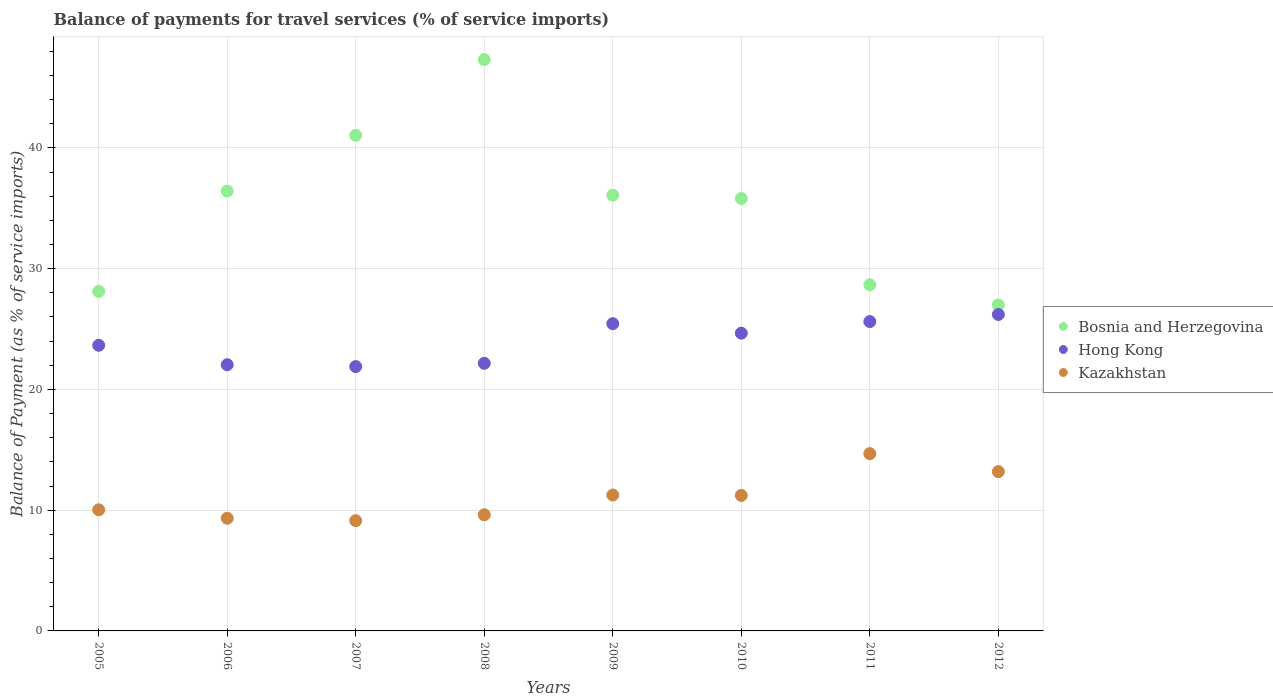What is the balance of payments for travel services in Kazakhstan in 2012?
Your answer should be compact. 13.19. Across all years, what is the maximum balance of payments for travel services in Hong Kong?
Ensure brevity in your answer.  26.2. Across all years, what is the minimum balance of payments for travel services in Hong Kong?
Make the answer very short. 21.89. What is the total balance of payments for travel services in Kazakhstan in the graph?
Your answer should be very brief. 88.45. What is the difference between the balance of payments for travel services in Kazakhstan in 2009 and that in 2011?
Offer a very short reply. -3.43. What is the difference between the balance of payments for travel services in Kazakhstan in 2011 and the balance of payments for travel services in Bosnia and Herzegovina in 2012?
Provide a short and direct response. -12.31. What is the average balance of payments for travel services in Hong Kong per year?
Your answer should be very brief. 23.96. In the year 2012, what is the difference between the balance of payments for travel services in Hong Kong and balance of payments for travel services in Bosnia and Herzegovina?
Your answer should be compact. -0.79. In how many years, is the balance of payments for travel services in Kazakhstan greater than 2 %?
Keep it short and to the point. 8. What is the ratio of the balance of payments for travel services in Hong Kong in 2006 to that in 2011?
Your answer should be very brief. 0.86. Is the balance of payments for travel services in Kazakhstan in 2006 less than that in 2007?
Provide a succinct answer. No. Is the difference between the balance of payments for travel services in Hong Kong in 2007 and 2012 greater than the difference between the balance of payments for travel services in Bosnia and Herzegovina in 2007 and 2012?
Your response must be concise. No. What is the difference between the highest and the second highest balance of payments for travel services in Bosnia and Herzegovina?
Ensure brevity in your answer.  6.27. What is the difference between the highest and the lowest balance of payments for travel services in Kazakhstan?
Make the answer very short. 5.55. Is it the case that in every year, the sum of the balance of payments for travel services in Bosnia and Herzegovina and balance of payments for travel services in Hong Kong  is greater than the balance of payments for travel services in Kazakhstan?
Give a very brief answer. Yes. Does the balance of payments for travel services in Hong Kong monotonically increase over the years?
Make the answer very short. No. Is the balance of payments for travel services in Hong Kong strictly greater than the balance of payments for travel services in Bosnia and Herzegovina over the years?
Make the answer very short. No. Is the balance of payments for travel services in Kazakhstan strictly less than the balance of payments for travel services in Bosnia and Herzegovina over the years?
Give a very brief answer. Yes. How many dotlines are there?
Provide a succinct answer. 3. Are the values on the major ticks of Y-axis written in scientific E-notation?
Your answer should be very brief. No. Does the graph contain any zero values?
Provide a succinct answer. No. Does the graph contain grids?
Provide a short and direct response. Yes. How many legend labels are there?
Ensure brevity in your answer.  3. What is the title of the graph?
Ensure brevity in your answer.  Balance of payments for travel services (% of service imports). What is the label or title of the Y-axis?
Provide a succinct answer. Balance of Payment (as % of service imports). What is the Balance of Payment (as % of service imports) in Bosnia and Herzegovina in 2005?
Your answer should be compact. 28.11. What is the Balance of Payment (as % of service imports) in Hong Kong in 2005?
Your response must be concise. 23.65. What is the Balance of Payment (as % of service imports) in Kazakhstan in 2005?
Provide a succinct answer. 10.03. What is the Balance of Payment (as % of service imports) of Bosnia and Herzegovina in 2006?
Provide a short and direct response. 36.42. What is the Balance of Payment (as % of service imports) of Hong Kong in 2006?
Keep it short and to the point. 22.04. What is the Balance of Payment (as % of service imports) in Kazakhstan in 2006?
Make the answer very short. 9.33. What is the Balance of Payment (as % of service imports) in Bosnia and Herzegovina in 2007?
Your response must be concise. 41.04. What is the Balance of Payment (as % of service imports) in Hong Kong in 2007?
Provide a short and direct response. 21.89. What is the Balance of Payment (as % of service imports) in Kazakhstan in 2007?
Make the answer very short. 9.13. What is the Balance of Payment (as % of service imports) of Bosnia and Herzegovina in 2008?
Your answer should be very brief. 47.31. What is the Balance of Payment (as % of service imports) of Hong Kong in 2008?
Your answer should be very brief. 22.16. What is the Balance of Payment (as % of service imports) in Kazakhstan in 2008?
Offer a very short reply. 9.62. What is the Balance of Payment (as % of service imports) in Bosnia and Herzegovina in 2009?
Your answer should be compact. 36.08. What is the Balance of Payment (as % of service imports) in Hong Kong in 2009?
Ensure brevity in your answer.  25.44. What is the Balance of Payment (as % of service imports) of Kazakhstan in 2009?
Your answer should be very brief. 11.25. What is the Balance of Payment (as % of service imports) in Bosnia and Herzegovina in 2010?
Give a very brief answer. 35.81. What is the Balance of Payment (as % of service imports) in Hong Kong in 2010?
Keep it short and to the point. 24.66. What is the Balance of Payment (as % of service imports) in Kazakhstan in 2010?
Make the answer very short. 11.22. What is the Balance of Payment (as % of service imports) of Bosnia and Herzegovina in 2011?
Offer a very short reply. 28.67. What is the Balance of Payment (as % of service imports) in Hong Kong in 2011?
Your response must be concise. 25.62. What is the Balance of Payment (as % of service imports) in Kazakhstan in 2011?
Your answer should be compact. 14.68. What is the Balance of Payment (as % of service imports) in Bosnia and Herzegovina in 2012?
Your answer should be very brief. 26.99. What is the Balance of Payment (as % of service imports) in Hong Kong in 2012?
Keep it short and to the point. 26.2. What is the Balance of Payment (as % of service imports) of Kazakhstan in 2012?
Your answer should be compact. 13.19. Across all years, what is the maximum Balance of Payment (as % of service imports) of Bosnia and Herzegovina?
Your answer should be very brief. 47.31. Across all years, what is the maximum Balance of Payment (as % of service imports) of Hong Kong?
Offer a very short reply. 26.2. Across all years, what is the maximum Balance of Payment (as % of service imports) of Kazakhstan?
Your response must be concise. 14.68. Across all years, what is the minimum Balance of Payment (as % of service imports) of Bosnia and Herzegovina?
Your answer should be very brief. 26.99. Across all years, what is the minimum Balance of Payment (as % of service imports) of Hong Kong?
Offer a very short reply. 21.89. Across all years, what is the minimum Balance of Payment (as % of service imports) in Kazakhstan?
Make the answer very short. 9.13. What is the total Balance of Payment (as % of service imports) of Bosnia and Herzegovina in the graph?
Give a very brief answer. 280.43. What is the total Balance of Payment (as % of service imports) in Hong Kong in the graph?
Give a very brief answer. 191.67. What is the total Balance of Payment (as % of service imports) in Kazakhstan in the graph?
Your response must be concise. 88.45. What is the difference between the Balance of Payment (as % of service imports) in Bosnia and Herzegovina in 2005 and that in 2006?
Ensure brevity in your answer.  -8.31. What is the difference between the Balance of Payment (as % of service imports) of Hong Kong in 2005 and that in 2006?
Give a very brief answer. 1.61. What is the difference between the Balance of Payment (as % of service imports) in Kazakhstan in 2005 and that in 2006?
Offer a terse response. 0.7. What is the difference between the Balance of Payment (as % of service imports) of Bosnia and Herzegovina in 2005 and that in 2007?
Provide a succinct answer. -12.93. What is the difference between the Balance of Payment (as % of service imports) in Hong Kong in 2005 and that in 2007?
Your response must be concise. 1.76. What is the difference between the Balance of Payment (as % of service imports) of Kazakhstan in 2005 and that in 2007?
Your answer should be compact. 0.9. What is the difference between the Balance of Payment (as % of service imports) in Bosnia and Herzegovina in 2005 and that in 2008?
Provide a succinct answer. -19.19. What is the difference between the Balance of Payment (as % of service imports) of Hong Kong in 2005 and that in 2008?
Your answer should be very brief. 1.49. What is the difference between the Balance of Payment (as % of service imports) in Kazakhstan in 2005 and that in 2008?
Ensure brevity in your answer.  0.41. What is the difference between the Balance of Payment (as % of service imports) in Bosnia and Herzegovina in 2005 and that in 2009?
Your response must be concise. -7.97. What is the difference between the Balance of Payment (as % of service imports) in Hong Kong in 2005 and that in 2009?
Give a very brief answer. -1.79. What is the difference between the Balance of Payment (as % of service imports) of Kazakhstan in 2005 and that in 2009?
Your response must be concise. -1.22. What is the difference between the Balance of Payment (as % of service imports) in Bosnia and Herzegovina in 2005 and that in 2010?
Offer a very short reply. -7.69. What is the difference between the Balance of Payment (as % of service imports) in Hong Kong in 2005 and that in 2010?
Give a very brief answer. -1. What is the difference between the Balance of Payment (as % of service imports) in Kazakhstan in 2005 and that in 2010?
Offer a very short reply. -1.19. What is the difference between the Balance of Payment (as % of service imports) in Bosnia and Herzegovina in 2005 and that in 2011?
Your answer should be compact. -0.55. What is the difference between the Balance of Payment (as % of service imports) in Hong Kong in 2005 and that in 2011?
Your response must be concise. -1.96. What is the difference between the Balance of Payment (as % of service imports) in Kazakhstan in 2005 and that in 2011?
Offer a terse response. -4.65. What is the difference between the Balance of Payment (as % of service imports) in Bosnia and Herzegovina in 2005 and that in 2012?
Provide a succinct answer. 1.12. What is the difference between the Balance of Payment (as % of service imports) of Hong Kong in 2005 and that in 2012?
Keep it short and to the point. -2.55. What is the difference between the Balance of Payment (as % of service imports) in Kazakhstan in 2005 and that in 2012?
Keep it short and to the point. -3.16. What is the difference between the Balance of Payment (as % of service imports) in Bosnia and Herzegovina in 2006 and that in 2007?
Give a very brief answer. -4.62. What is the difference between the Balance of Payment (as % of service imports) of Hong Kong in 2006 and that in 2007?
Give a very brief answer. 0.15. What is the difference between the Balance of Payment (as % of service imports) in Kazakhstan in 2006 and that in 2007?
Give a very brief answer. 0.2. What is the difference between the Balance of Payment (as % of service imports) of Bosnia and Herzegovina in 2006 and that in 2008?
Give a very brief answer. -10.88. What is the difference between the Balance of Payment (as % of service imports) in Hong Kong in 2006 and that in 2008?
Your response must be concise. -0.12. What is the difference between the Balance of Payment (as % of service imports) in Kazakhstan in 2006 and that in 2008?
Offer a terse response. -0.29. What is the difference between the Balance of Payment (as % of service imports) in Bosnia and Herzegovina in 2006 and that in 2009?
Your answer should be compact. 0.34. What is the difference between the Balance of Payment (as % of service imports) of Hong Kong in 2006 and that in 2009?
Offer a very short reply. -3.4. What is the difference between the Balance of Payment (as % of service imports) of Kazakhstan in 2006 and that in 2009?
Offer a very short reply. -1.92. What is the difference between the Balance of Payment (as % of service imports) in Bosnia and Herzegovina in 2006 and that in 2010?
Make the answer very short. 0.62. What is the difference between the Balance of Payment (as % of service imports) in Hong Kong in 2006 and that in 2010?
Your answer should be compact. -2.61. What is the difference between the Balance of Payment (as % of service imports) in Kazakhstan in 2006 and that in 2010?
Your answer should be very brief. -1.89. What is the difference between the Balance of Payment (as % of service imports) of Bosnia and Herzegovina in 2006 and that in 2011?
Ensure brevity in your answer.  7.76. What is the difference between the Balance of Payment (as % of service imports) of Hong Kong in 2006 and that in 2011?
Your answer should be compact. -3.57. What is the difference between the Balance of Payment (as % of service imports) in Kazakhstan in 2006 and that in 2011?
Your response must be concise. -5.35. What is the difference between the Balance of Payment (as % of service imports) of Bosnia and Herzegovina in 2006 and that in 2012?
Keep it short and to the point. 9.43. What is the difference between the Balance of Payment (as % of service imports) in Hong Kong in 2006 and that in 2012?
Ensure brevity in your answer.  -4.16. What is the difference between the Balance of Payment (as % of service imports) in Kazakhstan in 2006 and that in 2012?
Make the answer very short. -3.86. What is the difference between the Balance of Payment (as % of service imports) in Bosnia and Herzegovina in 2007 and that in 2008?
Keep it short and to the point. -6.27. What is the difference between the Balance of Payment (as % of service imports) of Hong Kong in 2007 and that in 2008?
Provide a short and direct response. -0.27. What is the difference between the Balance of Payment (as % of service imports) in Kazakhstan in 2007 and that in 2008?
Ensure brevity in your answer.  -0.49. What is the difference between the Balance of Payment (as % of service imports) of Bosnia and Herzegovina in 2007 and that in 2009?
Provide a succinct answer. 4.96. What is the difference between the Balance of Payment (as % of service imports) in Hong Kong in 2007 and that in 2009?
Ensure brevity in your answer.  -3.55. What is the difference between the Balance of Payment (as % of service imports) in Kazakhstan in 2007 and that in 2009?
Offer a very short reply. -2.12. What is the difference between the Balance of Payment (as % of service imports) of Bosnia and Herzegovina in 2007 and that in 2010?
Give a very brief answer. 5.23. What is the difference between the Balance of Payment (as % of service imports) in Hong Kong in 2007 and that in 2010?
Your response must be concise. -2.77. What is the difference between the Balance of Payment (as % of service imports) of Kazakhstan in 2007 and that in 2010?
Give a very brief answer. -2.09. What is the difference between the Balance of Payment (as % of service imports) in Bosnia and Herzegovina in 2007 and that in 2011?
Offer a terse response. 12.37. What is the difference between the Balance of Payment (as % of service imports) in Hong Kong in 2007 and that in 2011?
Your answer should be compact. -3.73. What is the difference between the Balance of Payment (as % of service imports) of Kazakhstan in 2007 and that in 2011?
Make the answer very short. -5.55. What is the difference between the Balance of Payment (as % of service imports) of Bosnia and Herzegovina in 2007 and that in 2012?
Your response must be concise. 14.05. What is the difference between the Balance of Payment (as % of service imports) in Hong Kong in 2007 and that in 2012?
Offer a terse response. -4.31. What is the difference between the Balance of Payment (as % of service imports) of Kazakhstan in 2007 and that in 2012?
Your response must be concise. -4.06. What is the difference between the Balance of Payment (as % of service imports) in Bosnia and Herzegovina in 2008 and that in 2009?
Keep it short and to the point. 11.23. What is the difference between the Balance of Payment (as % of service imports) in Hong Kong in 2008 and that in 2009?
Your response must be concise. -3.28. What is the difference between the Balance of Payment (as % of service imports) in Kazakhstan in 2008 and that in 2009?
Offer a terse response. -1.63. What is the difference between the Balance of Payment (as % of service imports) in Bosnia and Herzegovina in 2008 and that in 2010?
Your answer should be compact. 11.5. What is the difference between the Balance of Payment (as % of service imports) in Hong Kong in 2008 and that in 2010?
Keep it short and to the point. -2.49. What is the difference between the Balance of Payment (as % of service imports) in Kazakhstan in 2008 and that in 2010?
Make the answer very short. -1.6. What is the difference between the Balance of Payment (as % of service imports) in Bosnia and Herzegovina in 2008 and that in 2011?
Provide a short and direct response. 18.64. What is the difference between the Balance of Payment (as % of service imports) of Hong Kong in 2008 and that in 2011?
Your answer should be compact. -3.45. What is the difference between the Balance of Payment (as % of service imports) in Kazakhstan in 2008 and that in 2011?
Provide a short and direct response. -5.06. What is the difference between the Balance of Payment (as % of service imports) in Bosnia and Herzegovina in 2008 and that in 2012?
Make the answer very short. 20.32. What is the difference between the Balance of Payment (as % of service imports) of Hong Kong in 2008 and that in 2012?
Provide a short and direct response. -4.04. What is the difference between the Balance of Payment (as % of service imports) of Kazakhstan in 2008 and that in 2012?
Provide a short and direct response. -3.57. What is the difference between the Balance of Payment (as % of service imports) of Bosnia and Herzegovina in 2009 and that in 2010?
Your answer should be very brief. 0.28. What is the difference between the Balance of Payment (as % of service imports) in Hong Kong in 2009 and that in 2010?
Your response must be concise. 0.79. What is the difference between the Balance of Payment (as % of service imports) of Kazakhstan in 2009 and that in 2010?
Provide a succinct answer. 0.03. What is the difference between the Balance of Payment (as % of service imports) of Bosnia and Herzegovina in 2009 and that in 2011?
Make the answer very short. 7.42. What is the difference between the Balance of Payment (as % of service imports) in Hong Kong in 2009 and that in 2011?
Ensure brevity in your answer.  -0.17. What is the difference between the Balance of Payment (as % of service imports) of Kazakhstan in 2009 and that in 2011?
Your answer should be compact. -3.43. What is the difference between the Balance of Payment (as % of service imports) of Bosnia and Herzegovina in 2009 and that in 2012?
Ensure brevity in your answer.  9.09. What is the difference between the Balance of Payment (as % of service imports) in Hong Kong in 2009 and that in 2012?
Offer a very short reply. -0.76. What is the difference between the Balance of Payment (as % of service imports) of Kazakhstan in 2009 and that in 2012?
Your answer should be very brief. -1.94. What is the difference between the Balance of Payment (as % of service imports) of Bosnia and Herzegovina in 2010 and that in 2011?
Keep it short and to the point. 7.14. What is the difference between the Balance of Payment (as % of service imports) of Hong Kong in 2010 and that in 2011?
Your answer should be very brief. -0.96. What is the difference between the Balance of Payment (as % of service imports) in Kazakhstan in 2010 and that in 2011?
Provide a short and direct response. -3.46. What is the difference between the Balance of Payment (as % of service imports) of Bosnia and Herzegovina in 2010 and that in 2012?
Provide a succinct answer. 8.82. What is the difference between the Balance of Payment (as % of service imports) of Hong Kong in 2010 and that in 2012?
Keep it short and to the point. -1.55. What is the difference between the Balance of Payment (as % of service imports) in Kazakhstan in 2010 and that in 2012?
Your answer should be very brief. -1.97. What is the difference between the Balance of Payment (as % of service imports) in Bosnia and Herzegovina in 2011 and that in 2012?
Provide a succinct answer. 1.67. What is the difference between the Balance of Payment (as % of service imports) in Hong Kong in 2011 and that in 2012?
Your response must be concise. -0.59. What is the difference between the Balance of Payment (as % of service imports) of Kazakhstan in 2011 and that in 2012?
Provide a succinct answer. 1.49. What is the difference between the Balance of Payment (as % of service imports) of Bosnia and Herzegovina in 2005 and the Balance of Payment (as % of service imports) of Hong Kong in 2006?
Your answer should be very brief. 6.07. What is the difference between the Balance of Payment (as % of service imports) in Bosnia and Herzegovina in 2005 and the Balance of Payment (as % of service imports) in Kazakhstan in 2006?
Your answer should be compact. 18.79. What is the difference between the Balance of Payment (as % of service imports) of Hong Kong in 2005 and the Balance of Payment (as % of service imports) of Kazakhstan in 2006?
Your answer should be very brief. 14.32. What is the difference between the Balance of Payment (as % of service imports) in Bosnia and Herzegovina in 2005 and the Balance of Payment (as % of service imports) in Hong Kong in 2007?
Provide a short and direct response. 6.22. What is the difference between the Balance of Payment (as % of service imports) of Bosnia and Herzegovina in 2005 and the Balance of Payment (as % of service imports) of Kazakhstan in 2007?
Your answer should be compact. 18.99. What is the difference between the Balance of Payment (as % of service imports) of Hong Kong in 2005 and the Balance of Payment (as % of service imports) of Kazakhstan in 2007?
Provide a short and direct response. 14.52. What is the difference between the Balance of Payment (as % of service imports) in Bosnia and Herzegovina in 2005 and the Balance of Payment (as % of service imports) in Hong Kong in 2008?
Ensure brevity in your answer.  5.95. What is the difference between the Balance of Payment (as % of service imports) in Bosnia and Herzegovina in 2005 and the Balance of Payment (as % of service imports) in Kazakhstan in 2008?
Provide a succinct answer. 18.5. What is the difference between the Balance of Payment (as % of service imports) in Hong Kong in 2005 and the Balance of Payment (as % of service imports) in Kazakhstan in 2008?
Make the answer very short. 14.03. What is the difference between the Balance of Payment (as % of service imports) of Bosnia and Herzegovina in 2005 and the Balance of Payment (as % of service imports) of Hong Kong in 2009?
Your answer should be very brief. 2.67. What is the difference between the Balance of Payment (as % of service imports) in Bosnia and Herzegovina in 2005 and the Balance of Payment (as % of service imports) in Kazakhstan in 2009?
Your answer should be compact. 16.86. What is the difference between the Balance of Payment (as % of service imports) in Hong Kong in 2005 and the Balance of Payment (as % of service imports) in Kazakhstan in 2009?
Your response must be concise. 12.4. What is the difference between the Balance of Payment (as % of service imports) of Bosnia and Herzegovina in 2005 and the Balance of Payment (as % of service imports) of Hong Kong in 2010?
Ensure brevity in your answer.  3.46. What is the difference between the Balance of Payment (as % of service imports) of Bosnia and Herzegovina in 2005 and the Balance of Payment (as % of service imports) of Kazakhstan in 2010?
Offer a very short reply. 16.89. What is the difference between the Balance of Payment (as % of service imports) in Hong Kong in 2005 and the Balance of Payment (as % of service imports) in Kazakhstan in 2010?
Make the answer very short. 12.43. What is the difference between the Balance of Payment (as % of service imports) of Bosnia and Herzegovina in 2005 and the Balance of Payment (as % of service imports) of Hong Kong in 2011?
Provide a short and direct response. 2.5. What is the difference between the Balance of Payment (as % of service imports) of Bosnia and Herzegovina in 2005 and the Balance of Payment (as % of service imports) of Kazakhstan in 2011?
Give a very brief answer. 13.44. What is the difference between the Balance of Payment (as % of service imports) in Hong Kong in 2005 and the Balance of Payment (as % of service imports) in Kazakhstan in 2011?
Offer a very short reply. 8.97. What is the difference between the Balance of Payment (as % of service imports) of Bosnia and Herzegovina in 2005 and the Balance of Payment (as % of service imports) of Hong Kong in 2012?
Give a very brief answer. 1.91. What is the difference between the Balance of Payment (as % of service imports) of Bosnia and Herzegovina in 2005 and the Balance of Payment (as % of service imports) of Kazakhstan in 2012?
Keep it short and to the point. 14.93. What is the difference between the Balance of Payment (as % of service imports) of Hong Kong in 2005 and the Balance of Payment (as % of service imports) of Kazakhstan in 2012?
Offer a very short reply. 10.46. What is the difference between the Balance of Payment (as % of service imports) in Bosnia and Herzegovina in 2006 and the Balance of Payment (as % of service imports) in Hong Kong in 2007?
Provide a short and direct response. 14.53. What is the difference between the Balance of Payment (as % of service imports) in Bosnia and Herzegovina in 2006 and the Balance of Payment (as % of service imports) in Kazakhstan in 2007?
Keep it short and to the point. 27.3. What is the difference between the Balance of Payment (as % of service imports) of Hong Kong in 2006 and the Balance of Payment (as % of service imports) of Kazakhstan in 2007?
Give a very brief answer. 12.92. What is the difference between the Balance of Payment (as % of service imports) in Bosnia and Herzegovina in 2006 and the Balance of Payment (as % of service imports) in Hong Kong in 2008?
Provide a succinct answer. 14.26. What is the difference between the Balance of Payment (as % of service imports) of Bosnia and Herzegovina in 2006 and the Balance of Payment (as % of service imports) of Kazakhstan in 2008?
Offer a very short reply. 26.8. What is the difference between the Balance of Payment (as % of service imports) of Hong Kong in 2006 and the Balance of Payment (as % of service imports) of Kazakhstan in 2008?
Keep it short and to the point. 12.42. What is the difference between the Balance of Payment (as % of service imports) of Bosnia and Herzegovina in 2006 and the Balance of Payment (as % of service imports) of Hong Kong in 2009?
Keep it short and to the point. 10.98. What is the difference between the Balance of Payment (as % of service imports) in Bosnia and Herzegovina in 2006 and the Balance of Payment (as % of service imports) in Kazakhstan in 2009?
Provide a short and direct response. 25.17. What is the difference between the Balance of Payment (as % of service imports) in Hong Kong in 2006 and the Balance of Payment (as % of service imports) in Kazakhstan in 2009?
Keep it short and to the point. 10.79. What is the difference between the Balance of Payment (as % of service imports) of Bosnia and Herzegovina in 2006 and the Balance of Payment (as % of service imports) of Hong Kong in 2010?
Provide a succinct answer. 11.77. What is the difference between the Balance of Payment (as % of service imports) of Bosnia and Herzegovina in 2006 and the Balance of Payment (as % of service imports) of Kazakhstan in 2010?
Offer a very short reply. 25.2. What is the difference between the Balance of Payment (as % of service imports) of Hong Kong in 2006 and the Balance of Payment (as % of service imports) of Kazakhstan in 2010?
Offer a very short reply. 10.82. What is the difference between the Balance of Payment (as % of service imports) of Bosnia and Herzegovina in 2006 and the Balance of Payment (as % of service imports) of Hong Kong in 2011?
Your response must be concise. 10.81. What is the difference between the Balance of Payment (as % of service imports) of Bosnia and Herzegovina in 2006 and the Balance of Payment (as % of service imports) of Kazakhstan in 2011?
Your answer should be compact. 21.74. What is the difference between the Balance of Payment (as % of service imports) in Hong Kong in 2006 and the Balance of Payment (as % of service imports) in Kazakhstan in 2011?
Ensure brevity in your answer.  7.36. What is the difference between the Balance of Payment (as % of service imports) of Bosnia and Herzegovina in 2006 and the Balance of Payment (as % of service imports) of Hong Kong in 2012?
Your answer should be very brief. 10.22. What is the difference between the Balance of Payment (as % of service imports) of Bosnia and Herzegovina in 2006 and the Balance of Payment (as % of service imports) of Kazakhstan in 2012?
Offer a very short reply. 23.23. What is the difference between the Balance of Payment (as % of service imports) in Hong Kong in 2006 and the Balance of Payment (as % of service imports) in Kazakhstan in 2012?
Make the answer very short. 8.85. What is the difference between the Balance of Payment (as % of service imports) of Bosnia and Herzegovina in 2007 and the Balance of Payment (as % of service imports) of Hong Kong in 2008?
Provide a succinct answer. 18.88. What is the difference between the Balance of Payment (as % of service imports) in Bosnia and Herzegovina in 2007 and the Balance of Payment (as % of service imports) in Kazakhstan in 2008?
Your answer should be compact. 31.42. What is the difference between the Balance of Payment (as % of service imports) of Hong Kong in 2007 and the Balance of Payment (as % of service imports) of Kazakhstan in 2008?
Keep it short and to the point. 12.27. What is the difference between the Balance of Payment (as % of service imports) in Bosnia and Herzegovina in 2007 and the Balance of Payment (as % of service imports) in Hong Kong in 2009?
Provide a short and direct response. 15.6. What is the difference between the Balance of Payment (as % of service imports) in Bosnia and Herzegovina in 2007 and the Balance of Payment (as % of service imports) in Kazakhstan in 2009?
Offer a terse response. 29.79. What is the difference between the Balance of Payment (as % of service imports) of Hong Kong in 2007 and the Balance of Payment (as % of service imports) of Kazakhstan in 2009?
Give a very brief answer. 10.64. What is the difference between the Balance of Payment (as % of service imports) in Bosnia and Herzegovina in 2007 and the Balance of Payment (as % of service imports) in Hong Kong in 2010?
Your answer should be compact. 16.38. What is the difference between the Balance of Payment (as % of service imports) in Bosnia and Herzegovina in 2007 and the Balance of Payment (as % of service imports) in Kazakhstan in 2010?
Provide a short and direct response. 29.82. What is the difference between the Balance of Payment (as % of service imports) in Hong Kong in 2007 and the Balance of Payment (as % of service imports) in Kazakhstan in 2010?
Offer a very short reply. 10.67. What is the difference between the Balance of Payment (as % of service imports) in Bosnia and Herzegovina in 2007 and the Balance of Payment (as % of service imports) in Hong Kong in 2011?
Provide a succinct answer. 15.42. What is the difference between the Balance of Payment (as % of service imports) of Bosnia and Herzegovina in 2007 and the Balance of Payment (as % of service imports) of Kazakhstan in 2011?
Make the answer very short. 26.36. What is the difference between the Balance of Payment (as % of service imports) of Hong Kong in 2007 and the Balance of Payment (as % of service imports) of Kazakhstan in 2011?
Your response must be concise. 7.21. What is the difference between the Balance of Payment (as % of service imports) of Bosnia and Herzegovina in 2007 and the Balance of Payment (as % of service imports) of Hong Kong in 2012?
Offer a very short reply. 14.84. What is the difference between the Balance of Payment (as % of service imports) in Bosnia and Herzegovina in 2007 and the Balance of Payment (as % of service imports) in Kazakhstan in 2012?
Keep it short and to the point. 27.85. What is the difference between the Balance of Payment (as % of service imports) of Hong Kong in 2007 and the Balance of Payment (as % of service imports) of Kazakhstan in 2012?
Offer a very short reply. 8.7. What is the difference between the Balance of Payment (as % of service imports) in Bosnia and Herzegovina in 2008 and the Balance of Payment (as % of service imports) in Hong Kong in 2009?
Offer a terse response. 21.86. What is the difference between the Balance of Payment (as % of service imports) in Bosnia and Herzegovina in 2008 and the Balance of Payment (as % of service imports) in Kazakhstan in 2009?
Provide a short and direct response. 36.05. What is the difference between the Balance of Payment (as % of service imports) of Hong Kong in 2008 and the Balance of Payment (as % of service imports) of Kazakhstan in 2009?
Provide a short and direct response. 10.91. What is the difference between the Balance of Payment (as % of service imports) in Bosnia and Herzegovina in 2008 and the Balance of Payment (as % of service imports) in Hong Kong in 2010?
Offer a terse response. 22.65. What is the difference between the Balance of Payment (as % of service imports) in Bosnia and Herzegovina in 2008 and the Balance of Payment (as % of service imports) in Kazakhstan in 2010?
Offer a very short reply. 36.09. What is the difference between the Balance of Payment (as % of service imports) of Hong Kong in 2008 and the Balance of Payment (as % of service imports) of Kazakhstan in 2010?
Provide a succinct answer. 10.94. What is the difference between the Balance of Payment (as % of service imports) in Bosnia and Herzegovina in 2008 and the Balance of Payment (as % of service imports) in Hong Kong in 2011?
Ensure brevity in your answer.  21.69. What is the difference between the Balance of Payment (as % of service imports) of Bosnia and Herzegovina in 2008 and the Balance of Payment (as % of service imports) of Kazakhstan in 2011?
Your answer should be compact. 32.63. What is the difference between the Balance of Payment (as % of service imports) in Hong Kong in 2008 and the Balance of Payment (as % of service imports) in Kazakhstan in 2011?
Offer a very short reply. 7.48. What is the difference between the Balance of Payment (as % of service imports) of Bosnia and Herzegovina in 2008 and the Balance of Payment (as % of service imports) of Hong Kong in 2012?
Offer a terse response. 21.1. What is the difference between the Balance of Payment (as % of service imports) of Bosnia and Herzegovina in 2008 and the Balance of Payment (as % of service imports) of Kazakhstan in 2012?
Offer a terse response. 34.12. What is the difference between the Balance of Payment (as % of service imports) of Hong Kong in 2008 and the Balance of Payment (as % of service imports) of Kazakhstan in 2012?
Offer a terse response. 8.97. What is the difference between the Balance of Payment (as % of service imports) of Bosnia and Herzegovina in 2009 and the Balance of Payment (as % of service imports) of Hong Kong in 2010?
Give a very brief answer. 11.43. What is the difference between the Balance of Payment (as % of service imports) in Bosnia and Herzegovina in 2009 and the Balance of Payment (as % of service imports) in Kazakhstan in 2010?
Your answer should be very brief. 24.86. What is the difference between the Balance of Payment (as % of service imports) in Hong Kong in 2009 and the Balance of Payment (as % of service imports) in Kazakhstan in 2010?
Your answer should be very brief. 14.22. What is the difference between the Balance of Payment (as % of service imports) in Bosnia and Herzegovina in 2009 and the Balance of Payment (as % of service imports) in Hong Kong in 2011?
Provide a short and direct response. 10.47. What is the difference between the Balance of Payment (as % of service imports) in Bosnia and Herzegovina in 2009 and the Balance of Payment (as % of service imports) in Kazakhstan in 2011?
Keep it short and to the point. 21.4. What is the difference between the Balance of Payment (as % of service imports) of Hong Kong in 2009 and the Balance of Payment (as % of service imports) of Kazakhstan in 2011?
Your response must be concise. 10.76. What is the difference between the Balance of Payment (as % of service imports) in Bosnia and Herzegovina in 2009 and the Balance of Payment (as % of service imports) in Hong Kong in 2012?
Offer a terse response. 9.88. What is the difference between the Balance of Payment (as % of service imports) of Bosnia and Herzegovina in 2009 and the Balance of Payment (as % of service imports) of Kazakhstan in 2012?
Make the answer very short. 22.89. What is the difference between the Balance of Payment (as % of service imports) of Hong Kong in 2009 and the Balance of Payment (as % of service imports) of Kazakhstan in 2012?
Keep it short and to the point. 12.25. What is the difference between the Balance of Payment (as % of service imports) of Bosnia and Herzegovina in 2010 and the Balance of Payment (as % of service imports) of Hong Kong in 2011?
Make the answer very short. 10.19. What is the difference between the Balance of Payment (as % of service imports) in Bosnia and Herzegovina in 2010 and the Balance of Payment (as % of service imports) in Kazakhstan in 2011?
Your answer should be compact. 21.13. What is the difference between the Balance of Payment (as % of service imports) of Hong Kong in 2010 and the Balance of Payment (as % of service imports) of Kazakhstan in 2011?
Provide a short and direct response. 9.98. What is the difference between the Balance of Payment (as % of service imports) in Bosnia and Herzegovina in 2010 and the Balance of Payment (as % of service imports) in Hong Kong in 2012?
Offer a terse response. 9.6. What is the difference between the Balance of Payment (as % of service imports) of Bosnia and Herzegovina in 2010 and the Balance of Payment (as % of service imports) of Kazakhstan in 2012?
Make the answer very short. 22.62. What is the difference between the Balance of Payment (as % of service imports) in Hong Kong in 2010 and the Balance of Payment (as % of service imports) in Kazakhstan in 2012?
Your answer should be very brief. 11.47. What is the difference between the Balance of Payment (as % of service imports) in Bosnia and Herzegovina in 2011 and the Balance of Payment (as % of service imports) in Hong Kong in 2012?
Keep it short and to the point. 2.46. What is the difference between the Balance of Payment (as % of service imports) of Bosnia and Herzegovina in 2011 and the Balance of Payment (as % of service imports) of Kazakhstan in 2012?
Ensure brevity in your answer.  15.48. What is the difference between the Balance of Payment (as % of service imports) in Hong Kong in 2011 and the Balance of Payment (as % of service imports) in Kazakhstan in 2012?
Make the answer very short. 12.43. What is the average Balance of Payment (as % of service imports) in Bosnia and Herzegovina per year?
Offer a terse response. 35.05. What is the average Balance of Payment (as % of service imports) of Hong Kong per year?
Offer a terse response. 23.96. What is the average Balance of Payment (as % of service imports) in Kazakhstan per year?
Keep it short and to the point. 11.06. In the year 2005, what is the difference between the Balance of Payment (as % of service imports) in Bosnia and Herzegovina and Balance of Payment (as % of service imports) in Hong Kong?
Provide a succinct answer. 4.46. In the year 2005, what is the difference between the Balance of Payment (as % of service imports) in Bosnia and Herzegovina and Balance of Payment (as % of service imports) in Kazakhstan?
Make the answer very short. 18.09. In the year 2005, what is the difference between the Balance of Payment (as % of service imports) of Hong Kong and Balance of Payment (as % of service imports) of Kazakhstan?
Provide a succinct answer. 13.62. In the year 2006, what is the difference between the Balance of Payment (as % of service imports) in Bosnia and Herzegovina and Balance of Payment (as % of service imports) in Hong Kong?
Provide a succinct answer. 14.38. In the year 2006, what is the difference between the Balance of Payment (as % of service imports) of Bosnia and Herzegovina and Balance of Payment (as % of service imports) of Kazakhstan?
Your answer should be compact. 27.09. In the year 2006, what is the difference between the Balance of Payment (as % of service imports) in Hong Kong and Balance of Payment (as % of service imports) in Kazakhstan?
Offer a terse response. 12.71. In the year 2007, what is the difference between the Balance of Payment (as % of service imports) of Bosnia and Herzegovina and Balance of Payment (as % of service imports) of Hong Kong?
Keep it short and to the point. 19.15. In the year 2007, what is the difference between the Balance of Payment (as % of service imports) in Bosnia and Herzegovina and Balance of Payment (as % of service imports) in Kazakhstan?
Provide a succinct answer. 31.91. In the year 2007, what is the difference between the Balance of Payment (as % of service imports) in Hong Kong and Balance of Payment (as % of service imports) in Kazakhstan?
Your response must be concise. 12.76. In the year 2008, what is the difference between the Balance of Payment (as % of service imports) of Bosnia and Herzegovina and Balance of Payment (as % of service imports) of Hong Kong?
Ensure brevity in your answer.  25.14. In the year 2008, what is the difference between the Balance of Payment (as % of service imports) in Bosnia and Herzegovina and Balance of Payment (as % of service imports) in Kazakhstan?
Your response must be concise. 37.69. In the year 2008, what is the difference between the Balance of Payment (as % of service imports) in Hong Kong and Balance of Payment (as % of service imports) in Kazakhstan?
Give a very brief answer. 12.54. In the year 2009, what is the difference between the Balance of Payment (as % of service imports) in Bosnia and Herzegovina and Balance of Payment (as % of service imports) in Hong Kong?
Make the answer very short. 10.64. In the year 2009, what is the difference between the Balance of Payment (as % of service imports) in Bosnia and Herzegovina and Balance of Payment (as % of service imports) in Kazakhstan?
Give a very brief answer. 24.83. In the year 2009, what is the difference between the Balance of Payment (as % of service imports) in Hong Kong and Balance of Payment (as % of service imports) in Kazakhstan?
Your response must be concise. 14.19. In the year 2010, what is the difference between the Balance of Payment (as % of service imports) of Bosnia and Herzegovina and Balance of Payment (as % of service imports) of Hong Kong?
Offer a very short reply. 11.15. In the year 2010, what is the difference between the Balance of Payment (as % of service imports) of Bosnia and Herzegovina and Balance of Payment (as % of service imports) of Kazakhstan?
Ensure brevity in your answer.  24.59. In the year 2010, what is the difference between the Balance of Payment (as % of service imports) in Hong Kong and Balance of Payment (as % of service imports) in Kazakhstan?
Your response must be concise. 13.44. In the year 2011, what is the difference between the Balance of Payment (as % of service imports) of Bosnia and Herzegovina and Balance of Payment (as % of service imports) of Hong Kong?
Keep it short and to the point. 3.05. In the year 2011, what is the difference between the Balance of Payment (as % of service imports) of Bosnia and Herzegovina and Balance of Payment (as % of service imports) of Kazakhstan?
Keep it short and to the point. 13.99. In the year 2011, what is the difference between the Balance of Payment (as % of service imports) of Hong Kong and Balance of Payment (as % of service imports) of Kazakhstan?
Give a very brief answer. 10.94. In the year 2012, what is the difference between the Balance of Payment (as % of service imports) in Bosnia and Herzegovina and Balance of Payment (as % of service imports) in Hong Kong?
Provide a succinct answer. 0.79. In the year 2012, what is the difference between the Balance of Payment (as % of service imports) of Bosnia and Herzegovina and Balance of Payment (as % of service imports) of Kazakhstan?
Provide a short and direct response. 13.8. In the year 2012, what is the difference between the Balance of Payment (as % of service imports) in Hong Kong and Balance of Payment (as % of service imports) in Kazakhstan?
Provide a short and direct response. 13.01. What is the ratio of the Balance of Payment (as % of service imports) of Bosnia and Herzegovina in 2005 to that in 2006?
Your answer should be very brief. 0.77. What is the ratio of the Balance of Payment (as % of service imports) of Hong Kong in 2005 to that in 2006?
Offer a terse response. 1.07. What is the ratio of the Balance of Payment (as % of service imports) of Kazakhstan in 2005 to that in 2006?
Make the answer very short. 1.08. What is the ratio of the Balance of Payment (as % of service imports) in Bosnia and Herzegovina in 2005 to that in 2007?
Your answer should be very brief. 0.69. What is the ratio of the Balance of Payment (as % of service imports) of Hong Kong in 2005 to that in 2007?
Provide a short and direct response. 1.08. What is the ratio of the Balance of Payment (as % of service imports) of Kazakhstan in 2005 to that in 2007?
Offer a very short reply. 1.1. What is the ratio of the Balance of Payment (as % of service imports) of Bosnia and Herzegovina in 2005 to that in 2008?
Make the answer very short. 0.59. What is the ratio of the Balance of Payment (as % of service imports) of Hong Kong in 2005 to that in 2008?
Make the answer very short. 1.07. What is the ratio of the Balance of Payment (as % of service imports) in Kazakhstan in 2005 to that in 2008?
Offer a terse response. 1.04. What is the ratio of the Balance of Payment (as % of service imports) in Bosnia and Herzegovina in 2005 to that in 2009?
Offer a terse response. 0.78. What is the ratio of the Balance of Payment (as % of service imports) of Hong Kong in 2005 to that in 2009?
Offer a terse response. 0.93. What is the ratio of the Balance of Payment (as % of service imports) of Kazakhstan in 2005 to that in 2009?
Ensure brevity in your answer.  0.89. What is the ratio of the Balance of Payment (as % of service imports) in Bosnia and Herzegovina in 2005 to that in 2010?
Ensure brevity in your answer.  0.79. What is the ratio of the Balance of Payment (as % of service imports) in Hong Kong in 2005 to that in 2010?
Provide a succinct answer. 0.96. What is the ratio of the Balance of Payment (as % of service imports) in Kazakhstan in 2005 to that in 2010?
Provide a short and direct response. 0.89. What is the ratio of the Balance of Payment (as % of service imports) in Bosnia and Herzegovina in 2005 to that in 2011?
Give a very brief answer. 0.98. What is the ratio of the Balance of Payment (as % of service imports) of Hong Kong in 2005 to that in 2011?
Keep it short and to the point. 0.92. What is the ratio of the Balance of Payment (as % of service imports) in Kazakhstan in 2005 to that in 2011?
Give a very brief answer. 0.68. What is the ratio of the Balance of Payment (as % of service imports) of Bosnia and Herzegovina in 2005 to that in 2012?
Your answer should be compact. 1.04. What is the ratio of the Balance of Payment (as % of service imports) of Hong Kong in 2005 to that in 2012?
Make the answer very short. 0.9. What is the ratio of the Balance of Payment (as % of service imports) in Kazakhstan in 2005 to that in 2012?
Your answer should be very brief. 0.76. What is the ratio of the Balance of Payment (as % of service imports) of Bosnia and Herzegovina in 2006 to that in 2007?
Give a very brief answer. 0.89. What is the ratio of the Balance of Payment (as % of service imports) of Bosnia and Herzegovina in 2006 to that in 2008?
Give a very brief answer. 0.77. What is the ratio of the Balance of Payment (as % of service imports) of Hong Kong in 2006 to that in 2008?
Ensure brevity in your answer.  0.99. What is the ratio of the Balance of Payment (as % of service imports) in Kazakhstan in 2006 to that in 2008?
Offer a terse response. 0.97. What is the ratio of the Balance of Payment (as % of service imports) in Bosnia and Herzegovina in 2006 to that in 2009?
Your response must be concise. 1.01. What is the ratio of the Balance of Payment (as % of service imports) in Hong Kong in 2006 to that in 2009?
Provide a succinct answer. 0.87. What is the ratio of the Balance of Payment (as % of service imports) in Kazakhstan in 2006 to that in 2009?
Your answer should be very brief. 0.83. What is the ratio of the Balance of Payment (as % of service imports) of Bosnia and Herzegovina in 2006 to that in 2010?
Your response must be concise. 1.02. What is the ratio of the Balance of Payment (as % of service imports) in Hong Kong in 2006 to that in 2010?
Provide a short and direct response. 0.89. What is the ratio of the Balance of Payment (as % of service imports) in Kazakhstan in 2006 to that in 2010?
Keep it short and to the point. 0.83. What is the ratio of the Balance of Payment (as % of service imports) in Bosnia and Herzegovina in 2006 to that in 2011?
Your answer should be compact. 1.27. What is the ratio of the Balance of Payment (as % of service imports) in Hong Kong in 2006 to that in 2011?
Your answer should be compact. 0.86. What is the ratio of the Balance of Payment (as % of service imports) of Kazakhstan in 2006 to that in 2011?
Provide a succinct answer. 0.64. What is the ratio of the Balance of Payment (as % of service imports) in Bosnia and Herzegovina in 2006 to that in 2012?
Your answer should be compact. 1.35. What is the ratio of the Balance of Payment (as % of service imports) of Hong Kong in 2006 to that in 2012?
Make the answer very short. 0.84. What is the ratio of the Balance of Payment (as % of service imports) in Kazakhstan in 2006 to that in 2012?
Give a very brief answer. 0.71. What is the ratio of the Balance of Payment (as % of service imports) of Bosnia and Herzegovina in 2007 to that in 2008?
Give a very brief answer. 0.87. What is the ratio of the Balance of Payment (as % of service imports) of Hong Kong in 2007 to that in 2008?
Offer a terse response. 0.99. What is the ratio of the Balance of Payment (as % of service imports) of Kazakhstan in 2007 to that in 2008?
Your answer should be compact. 0.95. What is the ratio of the Balance of Payment (as % of service imports) in Bosnia and Herzegovina in 2007 to that in 2009?
Your answer should be compact. 1.14. What is the ratio of the Balance of Payment (as % of service imports) of Hong Kong in 2007 to that in 2009?
Provide a succinct answer. 0.86. What is the ratio of the Balance of Payment (as % of service imports) of Kazakhstan in 2007 to that in 2009?
Your response must be concise. 0.81. What is the ratio of the Balance of Payment (as % of service imports) in Bosnia and Herzegovina in 2007 to that in 2010?
Give a very brief answer. 1.15. What is the ratio of the Balance of Payment (as % of service imports) in Hong Kong in 2007 to that in 2010?
Give a very brief answer. 0.89. What is the ratio of the Balance of Payment (as % of service imports) in Kazakhstan in 2007 to that in 2010?
Your answer should be very brief. 0.81. What is the ratio of the Balance of Payment (as % of service imports) in Bosnia and Herzegovina in 2007 to that in 2011?
Give a very brief answer. 1.43. What is the ratio of the Balance of Payment (as % of service imports) of Hong Kong in 2007 to that in 2011?
Your response must be concise. 0.85. What is the ratio of the Balance of Payment (as % of service imports) of Kazakhstan in 2007 to that in 2011?
Make the answer very short. 0.62. What is the ratio of the Balance of Payment (as % of service imports) in Bosnia and Herzegovina in 2007 to that in 2012?
Your answer should be very brief. 1.52. What is the ratio of the Balance of Payment (as % of service imports) of Hong Kong in 2007 to that in 2012?
Your answer should be compact. 0.84. What is the ratio of the Balance of Payment (as % of service imports) in Kazakhstan in 2007 to that in 2012?
Offer a terse response. 0.69. What is the ratio of the Balance of Payment (as % of service imports) in Bosnia and Herzegovina in 2008 to that in 2009?
Provide a succinct answer. 1.31. What is the ratio of the Balance of Payment (as % of service imports) of Hong Kong in 2008 to that in 2009?
Make the answer very short. 0.87. What is the ratio of the Balance of Payment (as % of service imports) in Kazakhstan in 2008 to that in 2009?
Offer a very short reply. 0.85. What is the ratio of the Balance of Payment (as % of service imports) of Bosnia and Herzegovina in 2008 to that in 2010?
Provide a short and direct response. 1.32. What is the ratio of the Balance of Payment (as % of service imports) of Hong Kong in 2008 to that in 2010?
Your response must be concise. 0.9. What is the ratio of the Balance of Payment (as % of service imports) of Kazakhstan in 2008 to that in 2010?
Offer a terse response. 0.86. What is the ratio of the Balance of Payment (as % of service imports) in Bosnia and Herzegovina in 2008 to that in 2011?
Offer a very short reply. 1.65. What is the ratio of the Balance of Payment (as % of service imports) of Hong Kong in 2008 to that in 2011?
Offer a terse response. 0.87. What is the ratio of the Balance of Payment (as % of service imports) in Kazakhstan in 2008 to that in 2011?
Your response must be concise. 0.66. What is the ratio of the Balance of Payment (as % of service imports) of Bosnia and Herzegovina in 2008 to that in 2012?
Keep it short and to the point. 1.75. What is the ratio of the Balance of Payment (as % of service imports) of Hong Kong in 2008 to that in 2012?
Provide a short and direct response. 0.85. What is the ratio of the Balance of Payment (as % of service imports) of Kazakhstan in 2008 to that in 2012?
Ensure brevity in your answer.  0.73. What is the ratio of the Balance of Payment (as % of service imports) of Bosnia and Herzegovina in 2009 to that in 2010?
Offer a very short reply. 1.01. What is the ratio of the Balance of Payment (as % of service imports) of Hong Kong in 2009 to that in 2010?
Your response must be concise. 1.03. What is the ratio of the Balance of Payment (as % of service imports) of Kazakhstan in 2009 to that in 2010?
Provide a short and direct response. 1. What is the ratio of the Balance of Payment (as % of service imports) in Bosnia and Herzegovina in 2009 to that in 2011?
Provide a short and direct response. 1.26. What is the ratio of the Balance of Payment (as % of service imports) of Kazakhstan in 2009 to that in 2011?
Provide a short and direct response. 0.77. What is the ratio of the Balance of Payment (as % of service imports) in Bosnia and Herzegovina in 2009 to that in 2012?
Give a very brief answer. 1.34. What is the ratio of the Balance of Payment (as % of service imports) of Hong Kong in 2009 to that in 2012?
Provide a succinct answer. 0.97. What is the ratio of the Balance of Payment (as % of service imports) in Kazakhstan in 2009 to that in 2012?
Provide a short and direct response. 0.85. What is the ratio of the Balance of Payment (as % of service imports) in Bosnia and Herzegovina in 2010 to that in 2011?
Ensure brevity in your answer.  1.25. What is the ratio of the Balance of Payment (as % of service imports) of Hong Kong in 2010 to that in 2011?
Provide a short and direct response. 0.96. What is the ratio of the Balance of Payment (as % of service imports) in Kazakhstan in 2010 to that in 2011?
Your response must be concise. 0.76. What is the ratio of the Balance of Payment (as % of service imports) in Bosnia and Herzegovina in 2010 to that in 2012?
Offer a very short reply. 1.33. What is the ratio of the Balance of Payment (as % of service imports) of Hong Kong in 2010 to that in 2012?
Your response must be concise. 0.94. What is the ratio of the Balance of Payment (as % of service imports) of Kazakhstan in 2010 to that in 2012?
Provide a short and direct response. 0.85. What is the ratio of the Balance of Payment (as % of service imports) in Bosnia and Herzegovina in 2011 to that in 2012?
Offer a terse response. 1.06. What is the ratio of the Balance of Payment (as % of service imports) of Hong Kong in 2011 to that in 2012?
Your answer should be very brief. 0.98. What is the ratio of the Balance of Payment (as % of service imports) in Kazakhstan in 2011 to that in 2012?
Give a very brief answer. 1.11. What is the difference between the highest and the second highest Balance of Payment (as % of service imports) in Bosnia and Herzegovina?
Offer a terse response. 6.27. What is the difference between the highest and the second highest Balance of Payment (as % of service imports) of Hong Kong?
Ensure brevity in your answer.  0.59. What is the difference between the highest and the second highest Balance of Payment (as % of service imports) in Kazakhstan?
Offer a very short reply. 1.49. What is the difference between the highest and the lowest Balance of Payment (as % of service imports) of Bosnia and Herzegovina?
Provide a succinct answer. 20.32. What is the difference between the highest and the lowest Balance of Payment (as % of service imports) of Hong Kong?
Offer a very short reply. 4.31. What is the difference between the highest and the lowest Balance of Payment (as % of service imports) in Kazakhstan?
Provide a succinct answer. 5.55. 